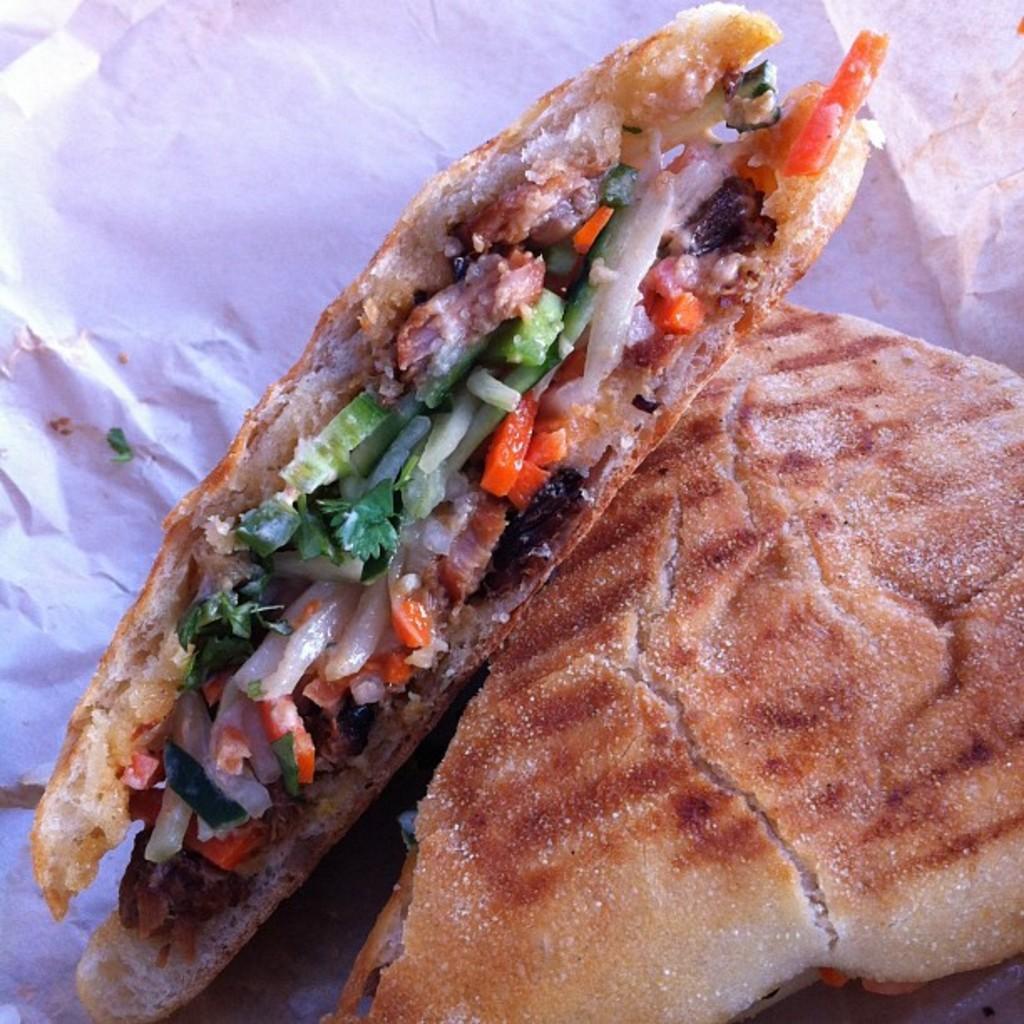Could you give a brief overview of what you see in this image? In this image on a paper there are sandwiches. 